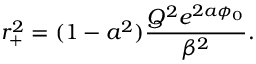<formula> <loc_0><loc_0><loc_500><loc_500>r _ { + } ^ { 2 } = ( 1 - a ^ { 2 } ) \frac { Q ^ { 2 } e ^ { 2 a \phi _ { 0 } } } { \beta ^ { 2 } } .</formula> 